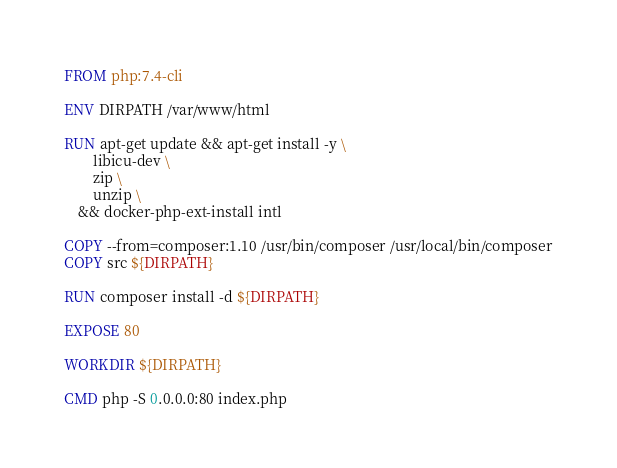Convert code to text. <code><loc_0><loc_0><loc_500><loc_500><_Dockerfile_>FROM php:7.4-cli

ENV DIRPATH /var/www/html

RUN apt-get update && apt-get install -y \
        libicu-dev \
        zip \
        unzip \
    && docker-php-ext-install intl

COPY --from=composer:1.10 /usr/bin/composer /usr/local/bin/composer
COPY src ${DIRPATH}

RUN composer install -d ${DIRPATH}

EXPOSE 80

WORKDIR ${DIRPATH}

CMD php -S 0.0.0.0:80 index.php
</code> 